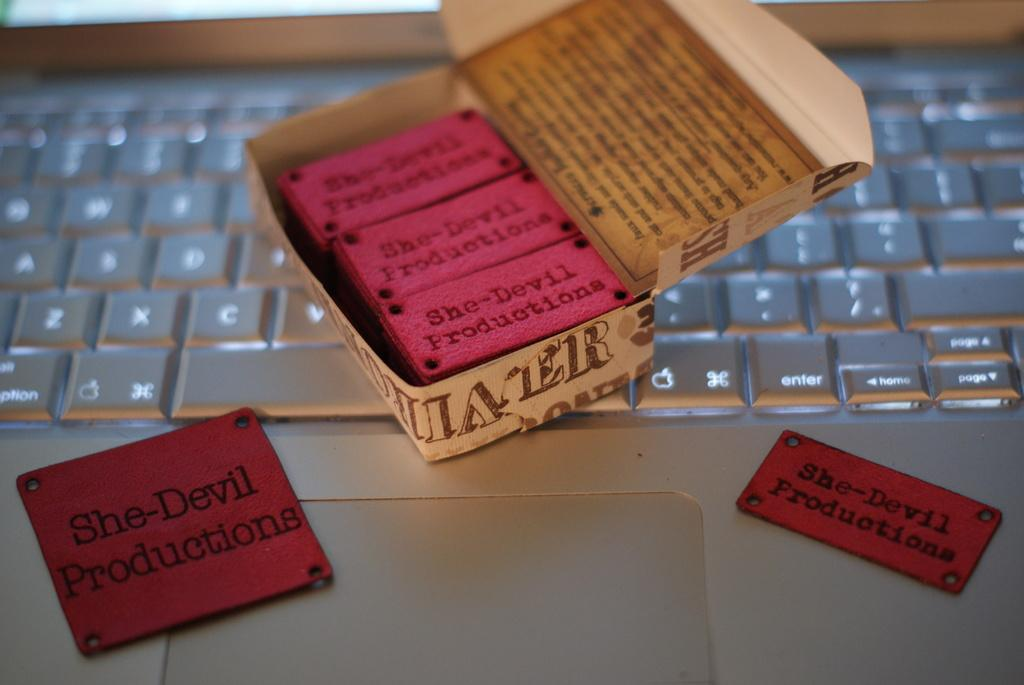<image>
Provide a brief description of the given image. She-Devil Productions labels sit on top of a laptop. 